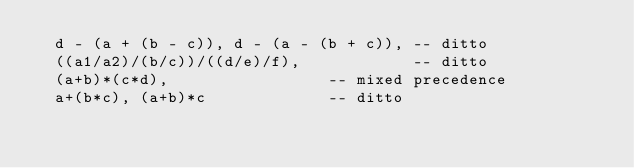<code> <loc_0><loc_0><loc_500><loc_500><_SQL_>  d - (a + (b - c)), d - (a - (b + c)), -- ditto
  ((a1/a2)/(b/c))/((d/e)/f),            -- ditto
  (a+b)*(c*d),                 -- mixed precedence
  a+(b*c), (a+b)*c             -- ditto
</code> 